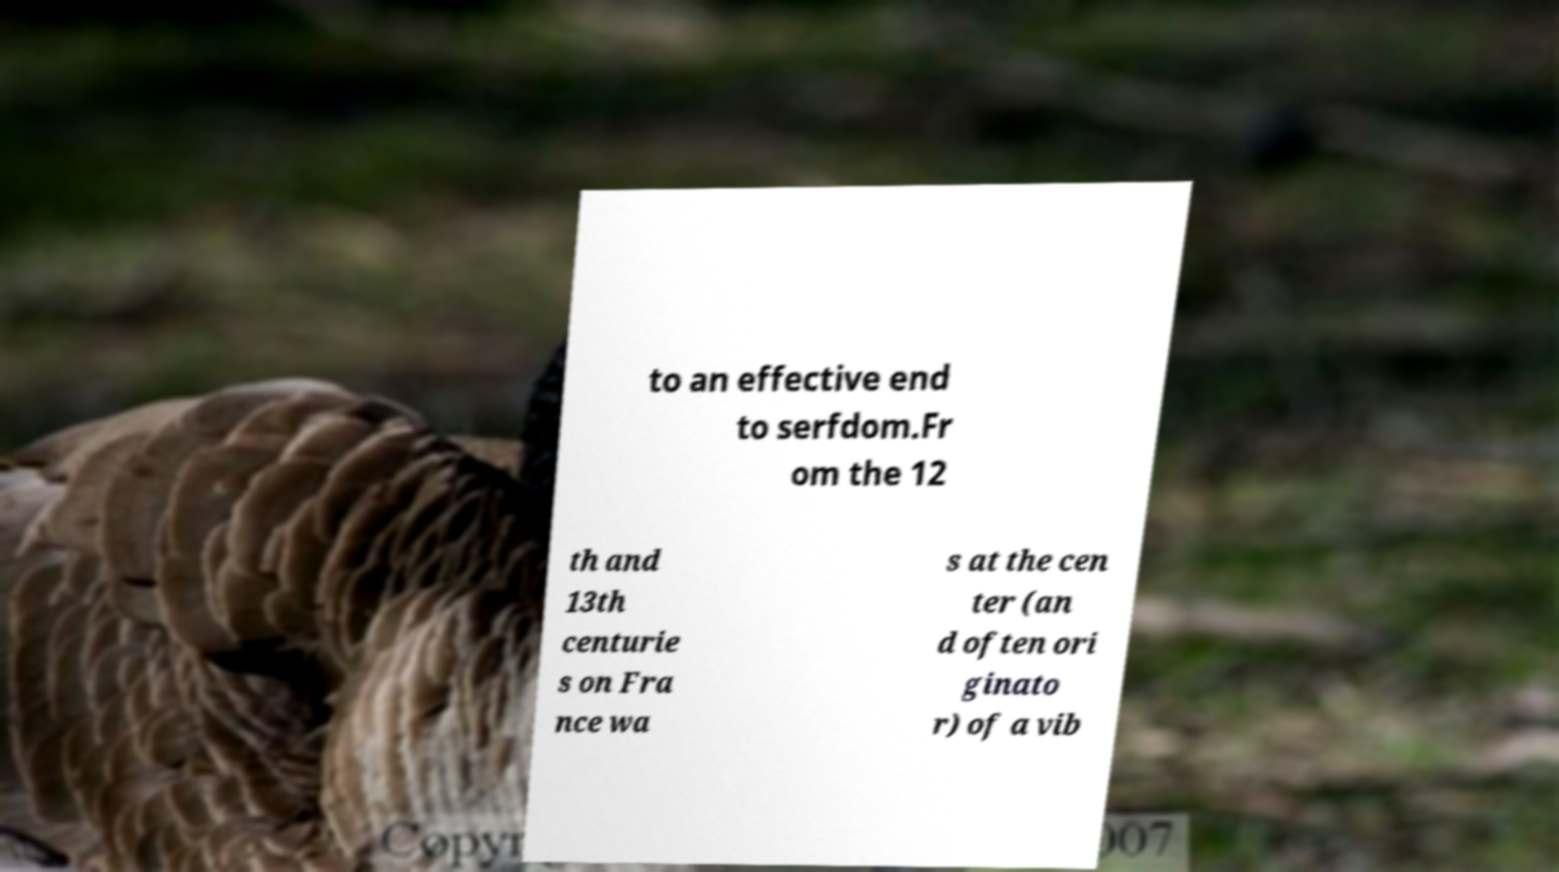Please identify and transcribe the text found in this image. to an effective end to serfdom.Fr om the 12 th and 13th centurie s on Fra nce wa s at the cen ter (an d often ori ginato r) of a vib 